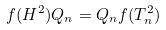<formula> <loc_0><loc_0><loc_500><loc_500>f ( H ^ { 2 } ) Q _ { n } = Q _ { n } f ( T _ { n } ^ { 2 } )</formula> 